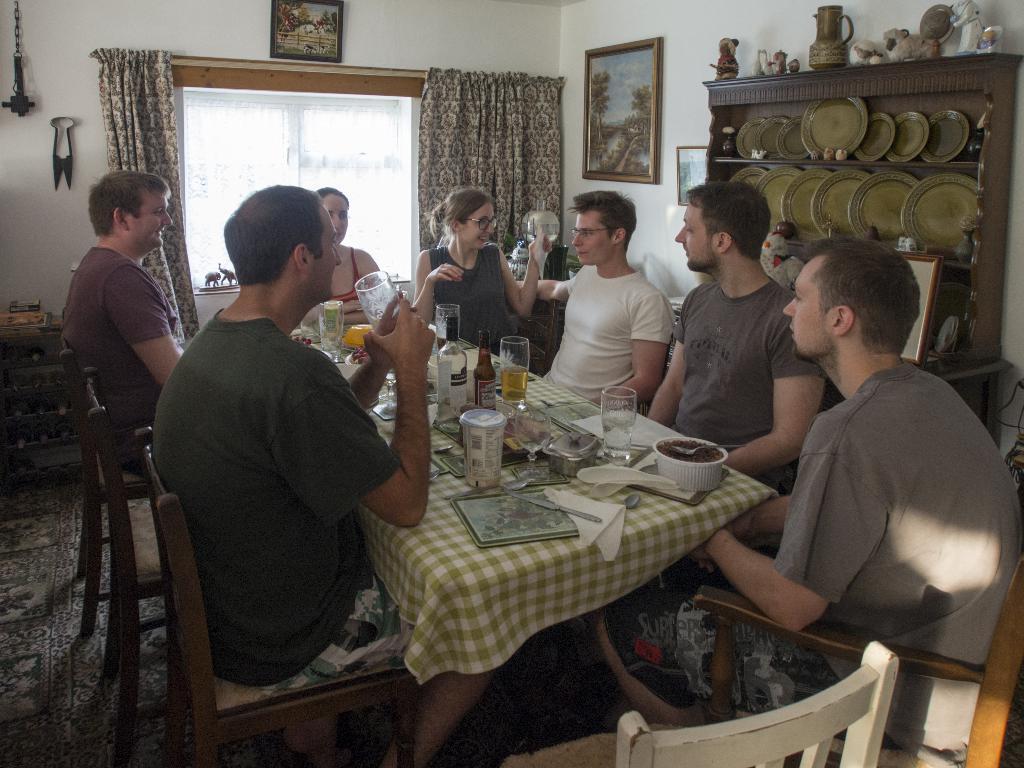Describe this image in one or two sentences. This is a room and few people are sitting at the table on the chair. On the table we can see cloth,spoon,knife,frame,glasses,wine bottle. He is holding glass. In the background we can see a wall,curtain and a window. There are two frames on the wall. There is a cupboard here with some plates. 